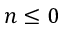<formula> <loc_0><loc_0><loc_500><loc_500>n \leq 0</formula> 